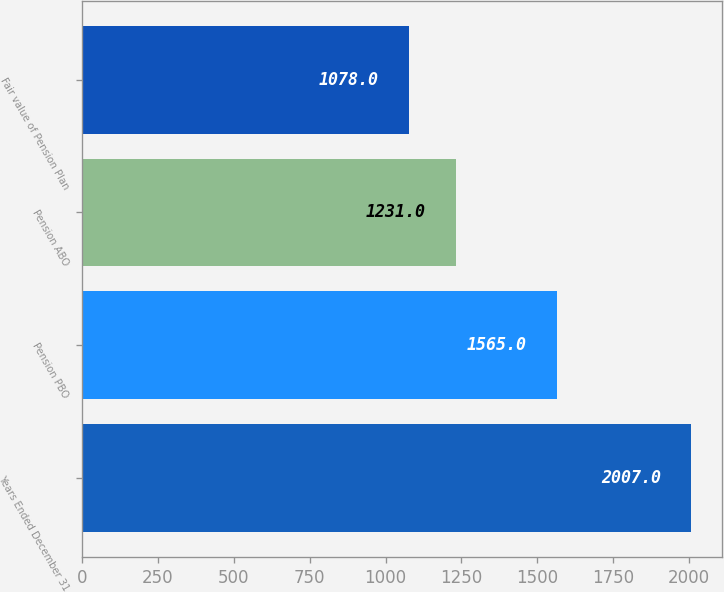Convert chart to OTSL. <chart><loc_0><loc_0><loc_500><loc_500><bar_chart><fcel>Years Ended December 31<fcel>Pension PBO<fcel>Pension ABO<fcel>Fair value of Pension Plan<nl><fcel>2007<fcel>1565<fcel>1231<fcel>1078<nl></chart> 